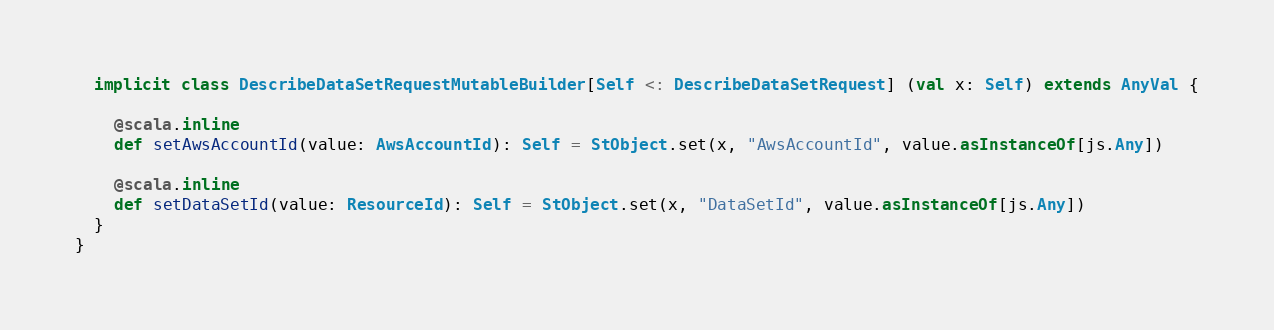<code> <loc_0><loc_0><loc_500><loc_500><_Scala_>  implicit class DescribeDataSetRequestMutableBuilder[Self <: DescribeDataSetRequest] (val x: Self) extends AnyVal {
    
    @scala.inline
    def setAwsAccountId(value: AwsAccountId): Self = StObject.set(x, "AwsAccountId", value.asInstanceOf[js.Any])
    
    @scala.inline
    def setDataSetId(value: ResourceId): Self = StObject.set(x, "DataSetId", value.asInstanceOf[js.Any])
  }
}
</code> 